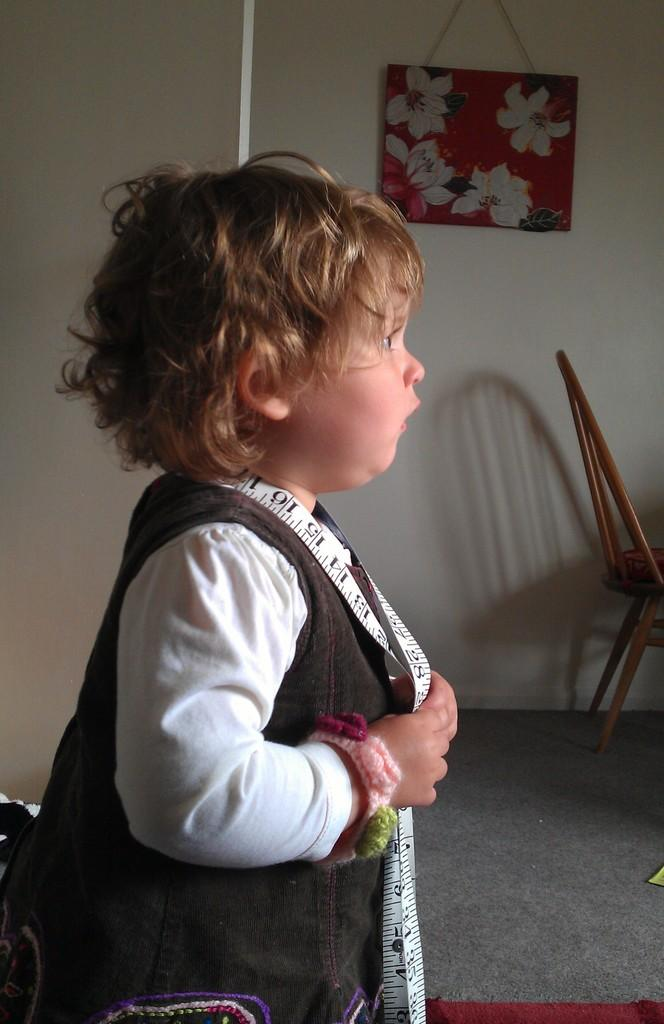What is the main subject of the image? There is a baby in the image. What is the baby doing in the image? The baby is standing in the image. What object is the baby holding in her hand? The baby is holding a measuring tape in her hand. What type of plate is the baby using to measure the distance in the image? There is no plate present in the image; the baby is holding a measuring tape. 